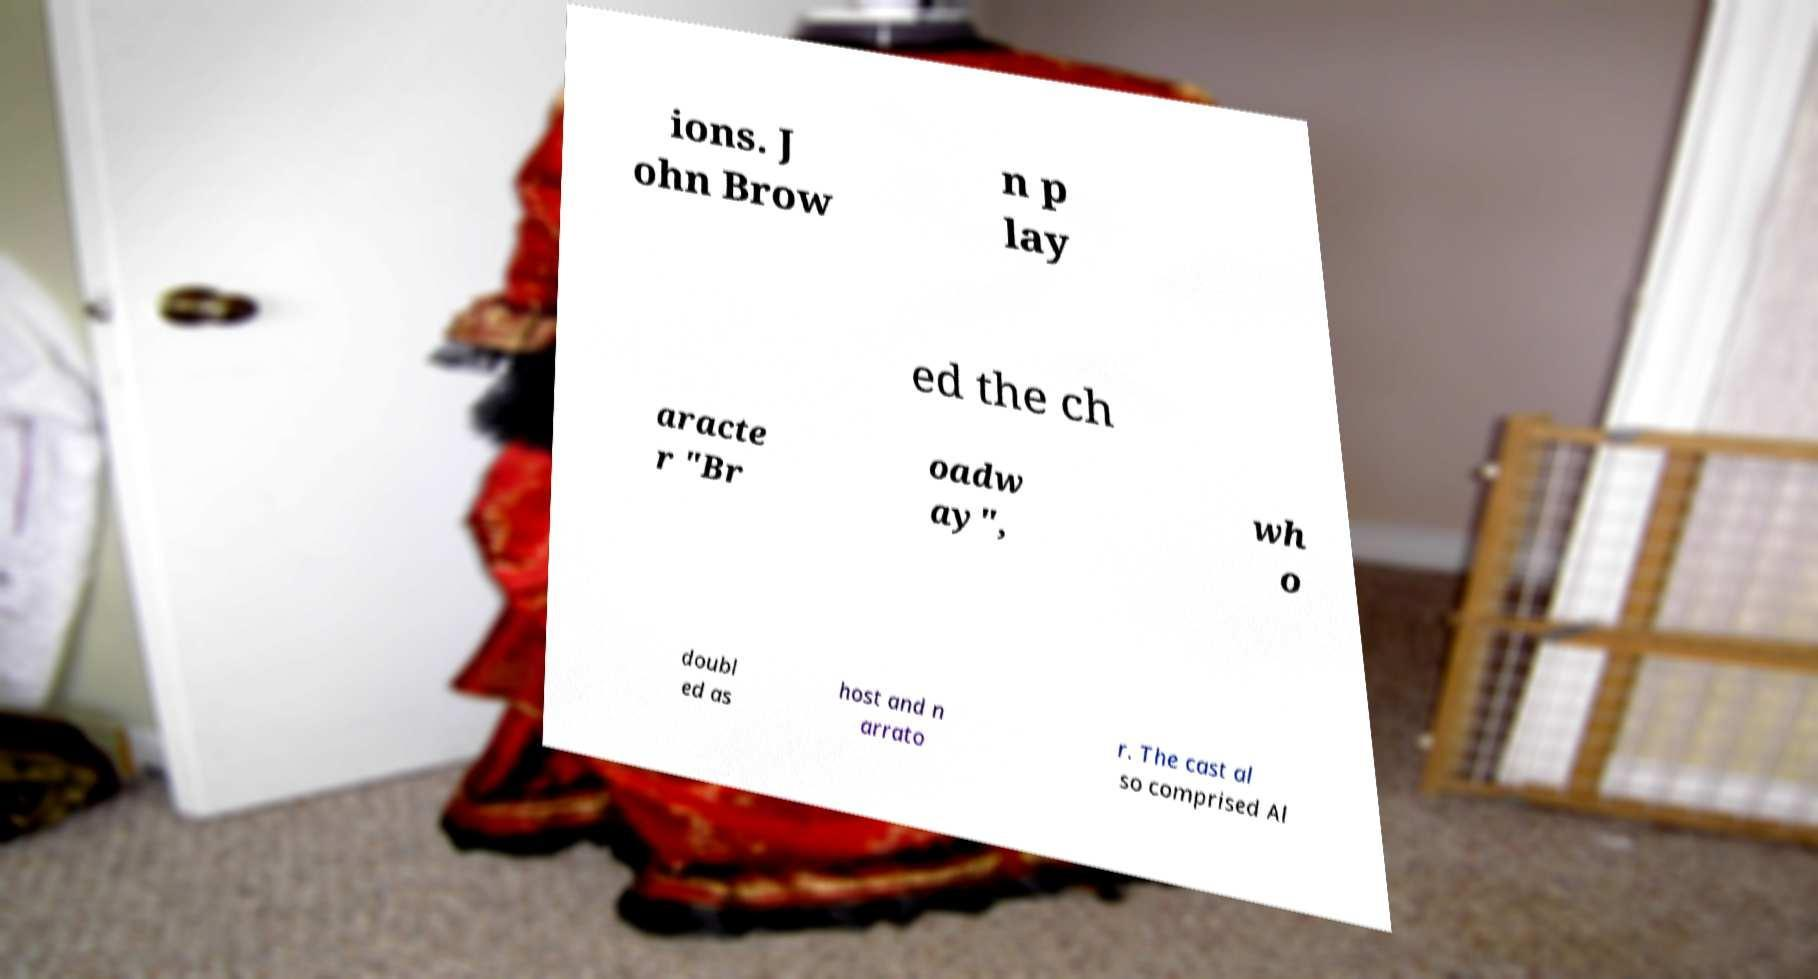Please read and relay the text visible in this image. What does it say? ions. J ohn Brow n p lay ed the ch aracte r "Br oadw ay", wh o doubl ed as host and n arrato r. The cast al so comprised Al 